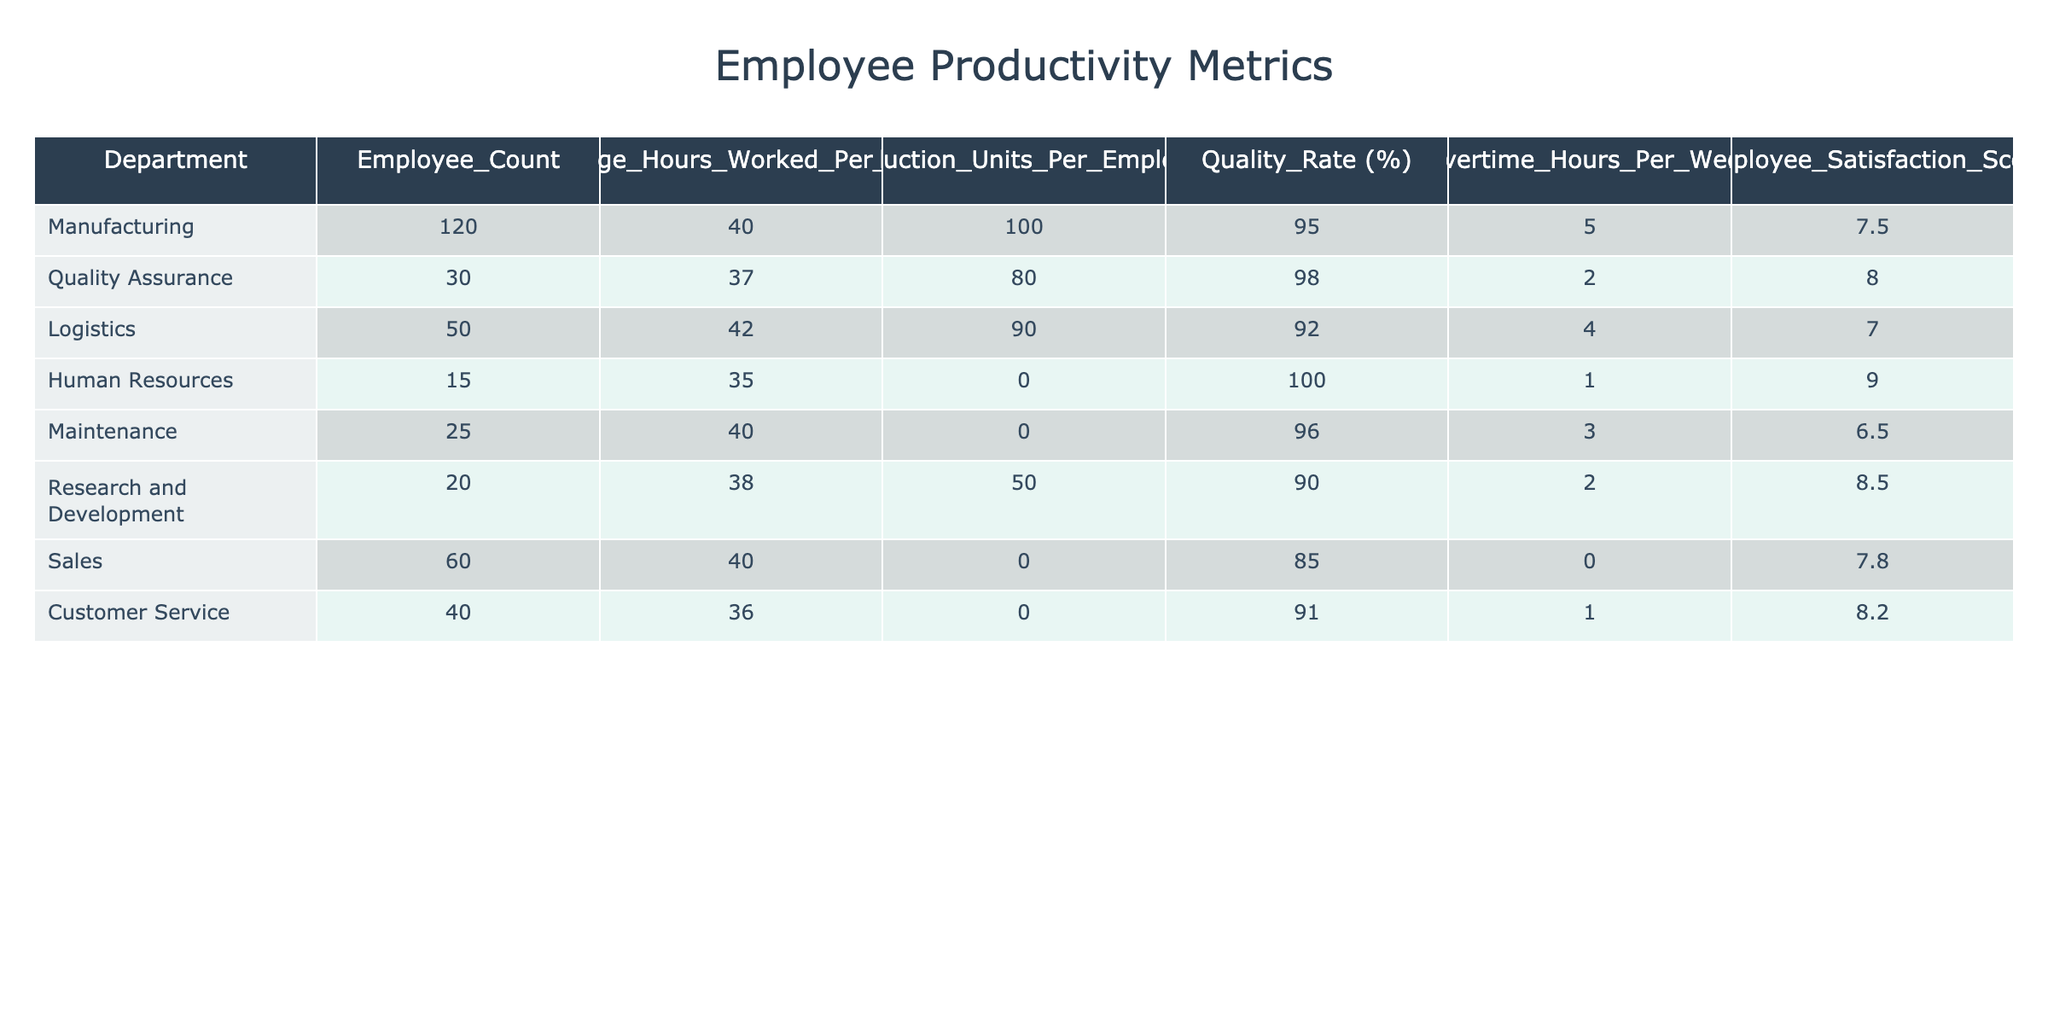What is the average employee satisfaction score across all departments? To find the average employee satisfaction score, we add all the scores and divide by the number of departments. The scores are 7.5, 8.0, 7.0, 9.0, 6.5, 8.5, 7.8, and 8.2. The total is 63.5, and there are 8 departments, so the average is 63.5 / 8 = 7.9375, which we can round to 7.94.
Answer: 7.94 Which department has the highest quality rate? To determine which department has the highest quality rate, we compare the quality rates from each department. The rates are 95% for Manufacturing, 98% for Quality Assurance, 92% for Logistics, 100% for Human Resources, 96% for Maintenance, 90% for Research and Development, 85% for Sales, and 91% for Customer Service. The highest is 100%, belonging to Human Resources.
Answer: Human Resources How many more average hours worked per week does the Manufacturing department have compared to the Maintenance department? We subtract the average hours worked in Maintenance from those in Manufacturing. Manufacturing has 40 hours, and Maintenance has 40 hours as well, resulting in 40 - 40 = 0. Thus, there is no difference in hours worked.
Answer: 0 True or False: The Research and Development department has a production rate higher than the Logistics department. We compare the production rates: Research and Development has 50 units per employee, while Logistics has 90 units per employee. Since 50 is less than 90, the statement is false.
Answer: False What is the total employee count in the Customer Service and Sales departments combined? To find the total employee count, we add the employee counts of both departments. Customer Service has 40 employees, and Sales has 60 employees. Thus, the total is 40 + 60 = 100.
Answer: 100 Which department works the most overtime hours per week on average? We compare the average overtime hours by examining the values: Manufacturing has 5, Quality Assurance has 2, Logistics has 4, Human Resources has 1, Maintenance has 3, Research and Development has 2, Sales has 0, and Customer Service has 1. Manufacturing has the highest average at 5 hours.
Answer: Manufacturing What is the percentage difference in quality rate between the highest and lowest department? The highest quality rate is 100% from Human Resources, and the lowest is 85% from Sales. The percentage difference is calculated as (100 - 85) / 100 * 100 = 15%.
Answer: 15% Which departments have a production rate of zero units per employee? To find the departments with a production rate of zero, we look through the table: Human Resources, Maintenance, and Sales all have a production rate of zero units per employee.
Answer: Human Resources, Maintenance, Sales 